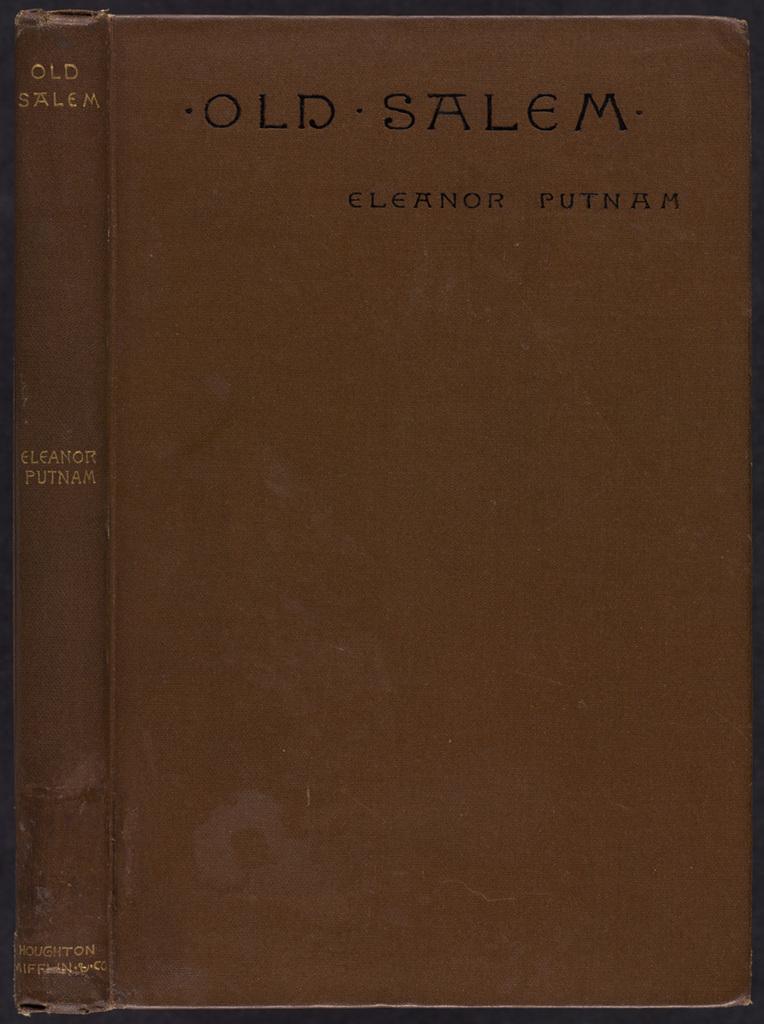Can you describe this image briefly? In this picture we can see a brown book and on the book it is written as " Old Salem". 